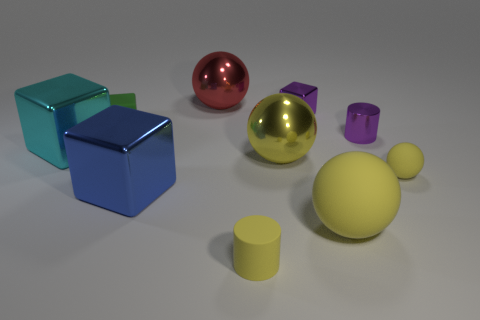How many yellow spheres must be subtracted to get 1 yellow spheres? 2 Subtract all red cylinders. How many yellow balls are left? 3 Subtract all balls. How many objects are left? 6 Add 4 tiny green objects. How many tiny green objects exist? 5 Subtract 0 purple spheres. How many objects are left? 10 Subtract all green metallic cylinders. Subtract all small rubber cylinders. How many objects are left? 9 Add 7 tiny green objects. How many tiny green objects are left? 8 